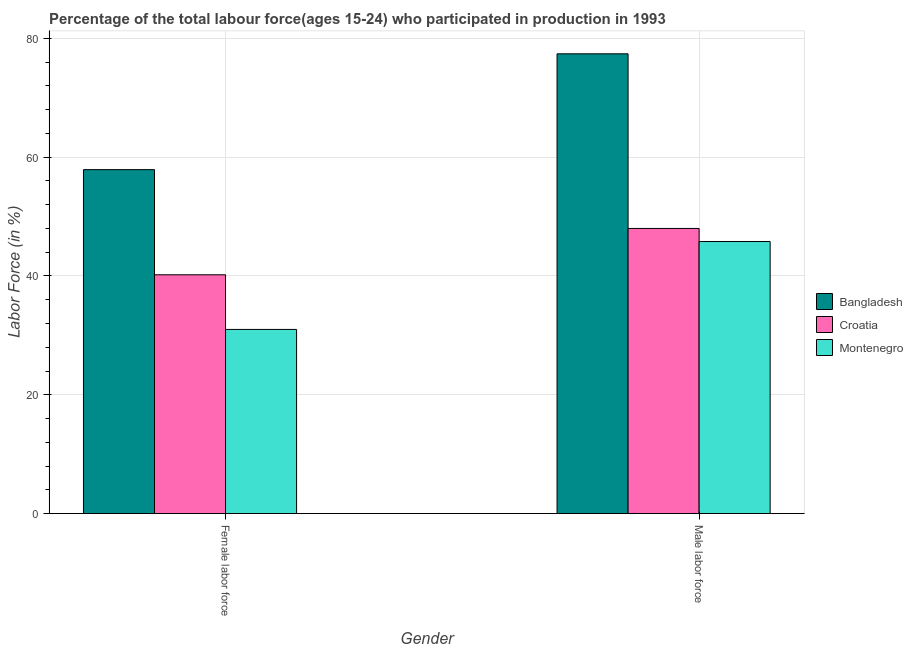Are the number of bars per tick equal to the number of legend labels?
Provide a succinct answer. Yes. How many bars are there on the 1st tick from the left?
Your answer should be compact. 3. What is the label of the 1st group of bars from the left?
Your answer should be very brief. Female labor force. What is the percentage of female labor force in Croatia?
Offer a terse response. 40.2. Across all countries, what is the maximum percentage of male labour force?
Give a very brief answer. 77.4. Across all countries, what is the minimum percentage of male labour force?
Provide a short and direct response. 45.8. In which country was the percentage of male labour force minimum?
Your answer should be very brief. Montenegro. What is the total percentage of female labor force in the graph?
Provide a succinct answer. 129.1. What is the difference between the percentage of male labour force in Bangladesh and that in Montenegro?
Offer a terse response. 31.6. What is the difference between the percentage of male labour force in Montenegro and the percentage of female labor force in Croatia?
Your answer should be very brief. 5.6. What is the average percentage of female labor force per country?
Provide a short and direct response. 43.03. What is the difference between the percentage of male labour force and percentage of female labor force in Montenegro?
Make the answer very short. 14.8. In how many countries, is the percentage of female labor force greater than 76 %?
Offer a very short reply. 0. What is the ratio of the percentage of female labor force in Montenegro to that in Croatia?
Provide a succinct answer. 0.77. Is the percentage of female labor force in Montenegro less than that in Bangladesh?
Ensure brevity in your answer.  Yes. What does the 3rd bar from the left in Male labor force represents?
Give a very brief answer. Montenegro. What does the 2nd bar from the right in Female labor force represents?
Your answer should be very brief. Croatia. How many bars are there?
Ensure brevity in your answer.  6. Are the values on the major ticks of Y-axis written in scientific E-notation?
Your answer should be compact. No. Does the graph contain grids?
Offer a terse response. Yes. What is the title of the graph?
Ensure brevity in your answer.  Percentage of the total labour force(ages 15-24) who participated in production in 1993. Does "Vietnam" appear as one of the legend labels in the graph?
Your response must be concise. No. What is the label or title of the X-axis?
Your answer should be compact. Gender. What is the label or title of the Y-axis?
Your answer should be compact. Labor Force (in %). What is the Labor Force (in %) of Bangladesh in Female labor force?
Your answer should be very brief. 57.9. What is the Labor Force (in %) in Croatia in Female labor force?
Keep it short and to the point. 40.2. What is the Labor Force (in %) in Montenegro in Female labor force?
Offer a very short reply. 31. What is the Labor Force (in %) in Bangladesh in Male labor force?
Make the answer very short. 77.4. What is the Labor Force (in %) of Croatia in Male labor force?
Provide a short and direct response. 48. What is the Labor Force (in %) of Montenegro in Male labor force?
Your answer should be compact. 45.8. Across all Gender, what is the maximum Labor Force (in %) in Bangladesh?
Your response must be concise. 77.4. Across all Gender, what is the maximum Labor Force (in %) of Croatia?
Give a very brief answer. 48. Across all Gender, what is the maximum Labor Force (in %) of Montenegro?
Make the answer very short. 45.8. Across all Gender, what is the minimum Labor Force (in %) in Bangladesh?
Ensure brevity in your answer.  57.9. Across all Gender, what is the minimum Labor Force (in %) in Croatia?
Ensure brevity in your answer.  40.2. What is the total Labor Force (in %) of Bangladesh in the graph?
Your answer should be compact. 135.3. What is the total Labor Force (in %) of Croatia in the graph?
Give a very brief answer. 88.2. What is the total Labor Force (in %) of Montenegro in the graph?
Your answer should be compact. 76.8. What is the difference between the Labor Force (in %) of Bangladesh in Female labor force and that in Male labor force?
Offer a terse response. -19.5. What is the difference between the Labor Force (in %) in Montenegro in Female labor force and that in Male labor force?
Offer a terse response. -14.8. What is the difference between the Labor Force (in %) in Bangladesh in Female labor force and the Labor Force (in %) in Montenegro in Male labor force?
Your answer should be very brief. 12.1. What is the difference between the Labor Force (in %) in Croatia in Female labor force and the Labor Force (in %) in Montenegro in Male labor force?
Your answer should be very brief. -5.6. What is the average Labor Force (in %) of Bangladesh per Gender?
Offer a very short reply. 67.65. What is the average Labor Force (in %) in Croatia per Gender?
Offer a very short reply. 44.1. What is the average Labor Force (in %) of Montenegro per Gender?
Give a very brief answer. 38.4. What is the difference between the Labor Force (in %) of Bangladesh and Labor Force (in %) of Croatia in Female labor force?
Give a very brief answer. 17.7. What is the difference between the Labor Force (in %) in Bangladesh and Labor Force (in %) in Montenegro in Female labor force?
Provide a succinct answer. 26.9. What is the difference between the Labor Force (in %) in Bangladesh and Labor Force (in %) in Croatia in Male labor force?
Provide a succinct answer. 29.4. What is the difference between the Labor Force (in %) of Bangladesh and Labor Force (in %) of Montenegro in Male labor force?
Your response must be concise. 31.6. What is the difference between the Labor Force (in %) in Croatia and Labor Force (in %) in Montenegro in Male labor force?
Provide a succinct answer. 2.2. What is the ratio of the Labor Force (in %) of Bangladesh in Female labor force to that in Male labor force?
Ensure brevity in your answer.  0.75. What is the ratio of the Labor Force (in %) of Croatia in Female labor force to that in Male labor force?
Your answer should be very brief. 0.84. What is the ratio of the Labor Force (in %) in Montenegro in Female labor force to that in Male labor force?
Your answer should be compact. 0.68. What is the difference between the highest and the second highest Labor Force (in %) in Bangladesh?
Offer a very short reply. 19.5. What is the difference between the highest and the second highest Labor Force (in %) in Croatia?
Offer a terse response. 7.8. What is the difference between the highest and the second highest Labor Force (in %) in Montenegro?
Your answer should be compact. 14.8. 